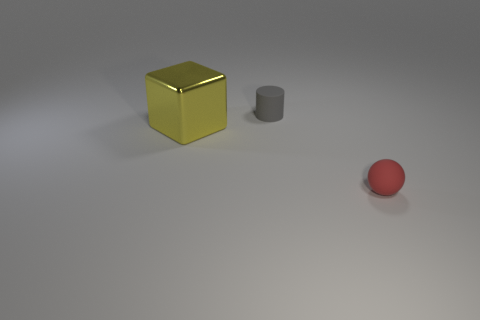Add 3 matte cylinders. How many objects exist? 6 Subtract 0 cyan cylinders. How many objects are left? 3 Subtract all cylinders. How many objects are left? 2 Subtract all shiny objects. Subtract all tiny rubber spheres. How many objects are left? 1 Add 1 tiny gray matte objects. How many tiny gray matte objects are left? 2 Add 1 brown blocks. How many brown blocks exist? 1 